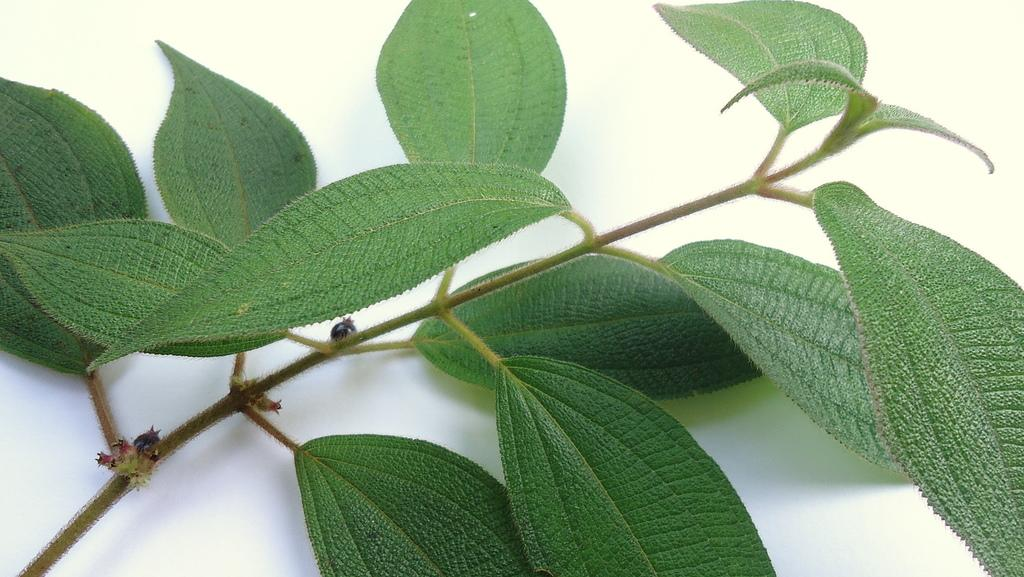What is the main subject of the image? The main subject of the image is a stem. What can be observed about the stem? The stem has leaves. What type of badge is attached to the stem in the image? There is no badge present in the image; it only features a stem with leaves. How is the stem being used in the image? The stem is not being used for any specific purpose in the image; it is simply depicted with leaves. 